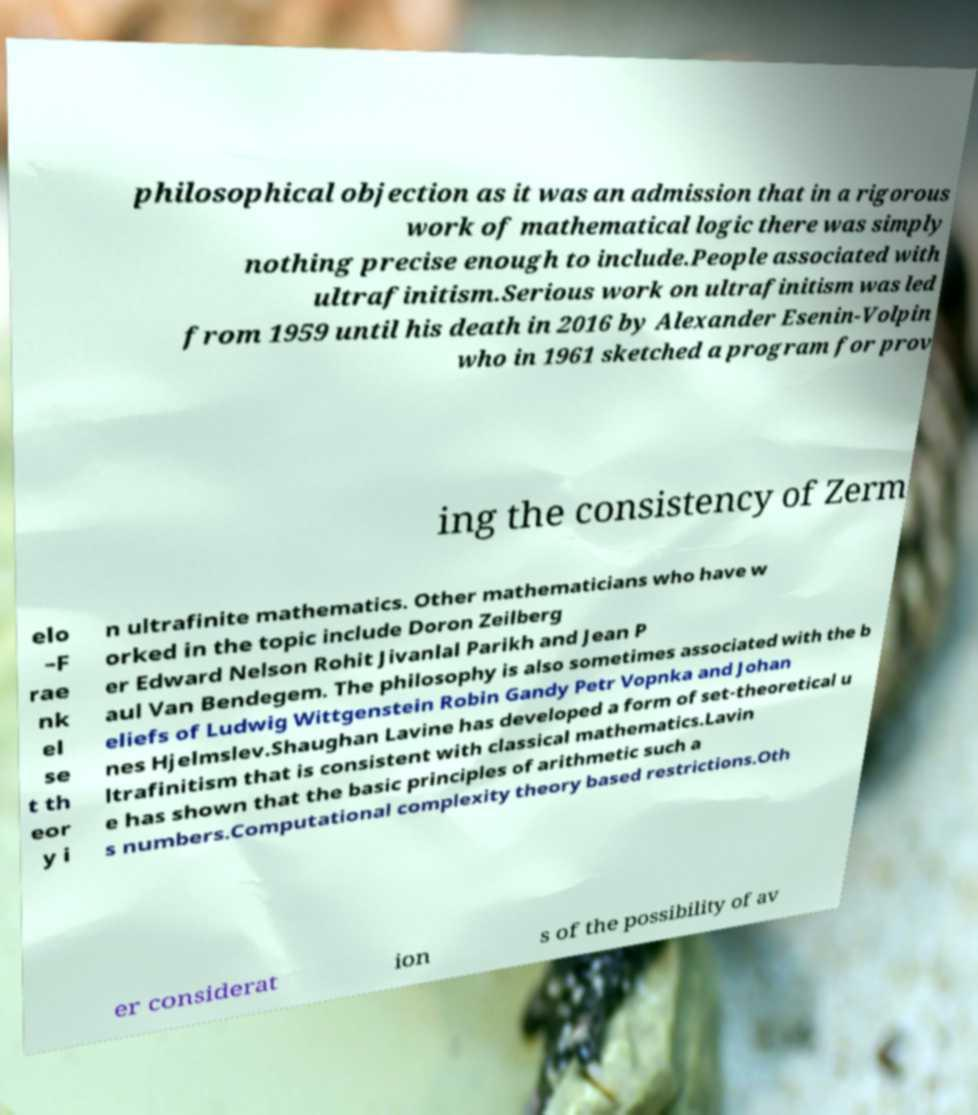Can you read and provide the text displayed in the image?This photo seems to have some interesting text. Can you extract and type it out for me? philosophical objection as it was an admission that in a rigorous work of mathematical logic there was simply nothing precise enough to include.People associated with ultrafinitism.Serious work on ultrafinitism was led from 1959 until his death in 2016 by Alexander Esenin-Volpin who in 1961 sketched a program for prov ing the consistency of Zerm elo –F rae nk el se t th eor y i n ultrafinite mathematics. Other mathematicians who have w orked in the topic include Doron Zeilberg er Edward Nelson Rohit Jivanlal Parikh and Jean P aul Van Bendegem. The philosophy is also sometimes associated with the b eliefs of Ludwig Wittgenstein Robin Gandy Petr Vopnka and Johan nes Hjelmslev.Shaughan Lavine has developed a form of set-theoretical u ltrafinitism that is consistent with classical mathematics.Lavin e has shown that the basic principles of arithmetic such a s numbers.Computational complexity theory based restrictions.Oth er considerat ion s of the possibility of av 